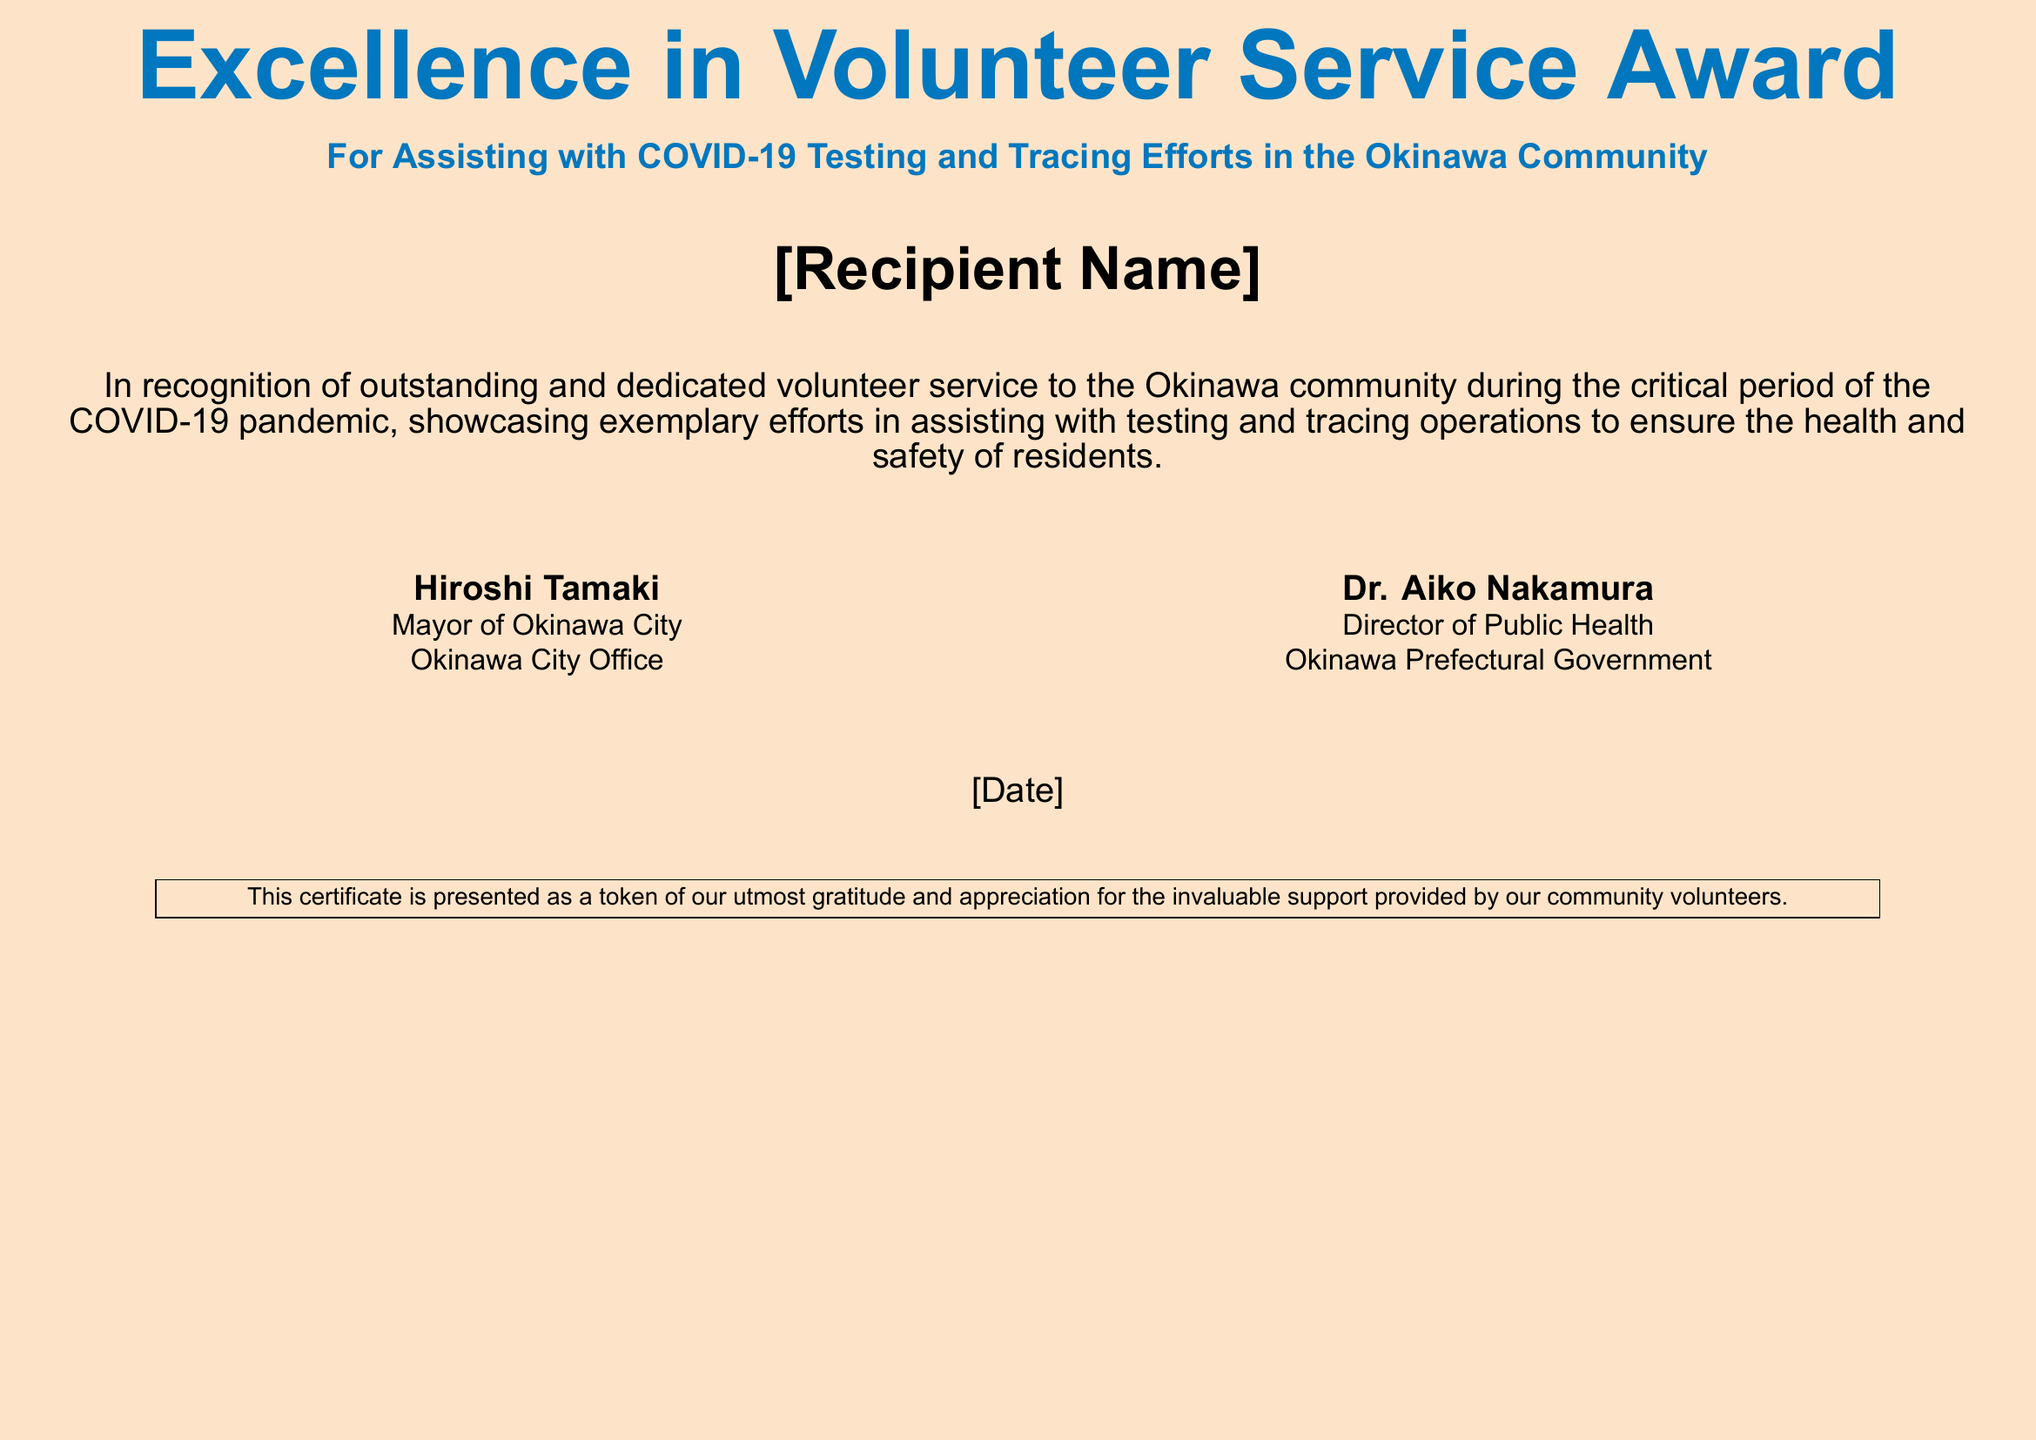what is the title of the award? The title is the heading of the document, which is presented prominently at the top.
Answer: Excellence in Volunteer Service Award who is the recipient of the certificate? The recipient's name placeholder indicates the individual who will receive the certificate.
Answer: [Recipient Name] who issued this certificate? The certificate includes the names of officials who are associated with the issuance.
Answer: Hiroshi Tamaki what role does Dr. Aiko Nakamura hold? Dr. Aiko Nakamura's position is stated under her name on the right side of the document.
Answer: Director of Public Health what was the purpose of the award? The recognition describes the actions the recipient assisted with during the pandemic.
Answer: Assisting with COVID-19 Testing and Tracing Efforts on what date was the award given? The date is a placeholder that shows when the certificate was issued.
Answer: [Date] who is the mayor of Okinawa City? The mayor's name is listed at the bottom left of the document.
Answer: Hiroshi Tamaki what color is the background of the certificate? The color specification is mentioned in the document setup.
Answer: Sandcolor what is expressed at the bottom of the document? The statement in the box highlights the sentiment towards the volunteers' contributions.
Answer: Gratitude and appreciation for the invaluable support 